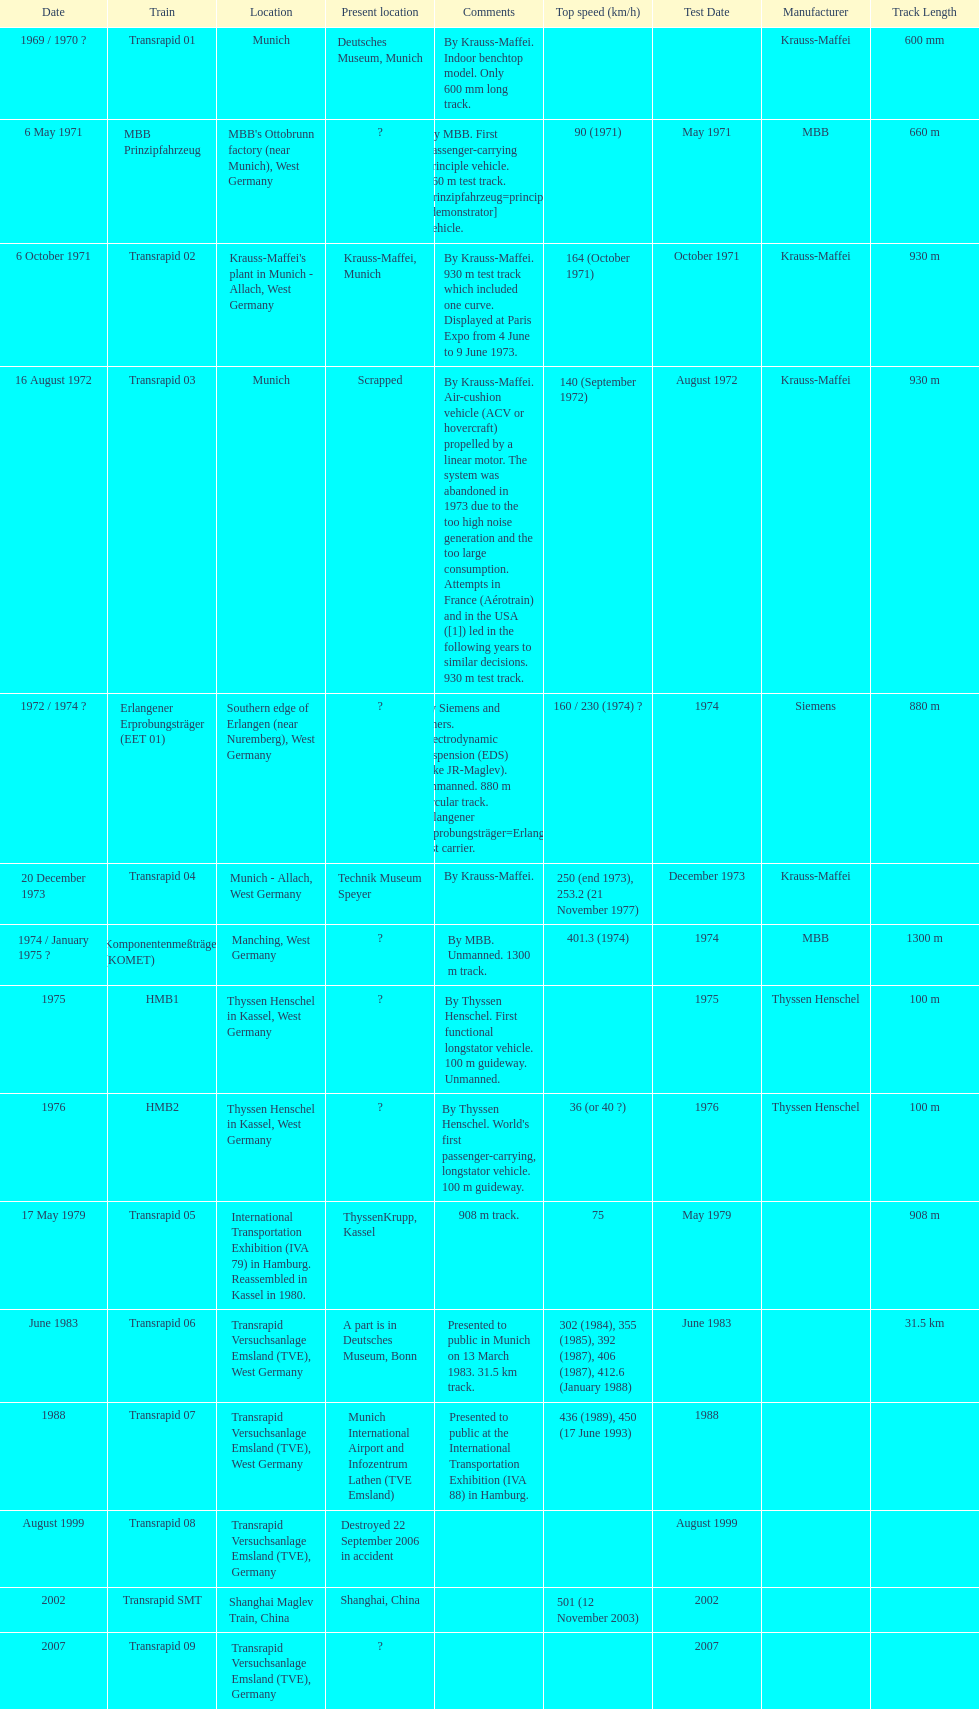How many trains other than the transrapid 07 can go faster than 450km/h? 1. 